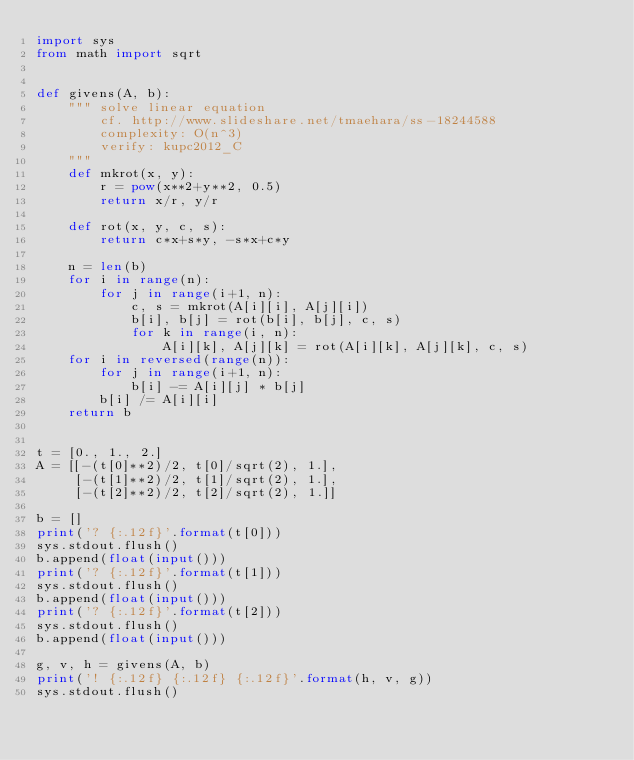<code> <loc_0><loc_0><loc_500><loc_500><_Python_>import sys
from math import sqrt


def givens(A, b):
    """ solve linear equation
        cf. http://www.slideshare.net/tmaehara/ss-18244588
        complexity: O(n^3)
        verify: kupc2012_C
    """
    def mkrot(x, y):
        r = pow(x**2+y**2, 0.5)
        return x/r, y/r

    def rot(x, y, c, s):
        return c*x+s*y, -s*x+c*y

    n = len(b)
    for i in range(n):
        for j in range(i+1, n):
            c, s = mkrot(A[i][i], A[j][i])
            b[i], b[j] = rot(b[i], b[j], c, s)
            for k in range(i, n):
                A[i][k], A[j][k] = rot(A[i][k], A[j][k], c, s)
    for i in reversed(range(n)):
        for j in range(i+1, n):
            b[i] -= A[i][j] * b[j]
        b[i] /= A[i][i]
    return b


t = [0., 1., 2.]
A = [[-(t[0]**2)/2, t[0]/sqrt(2), 1.],
     [-(t[1]**2)/2, t[1]/sqrt(2), 1.],
     [-(t[2]**2)/2, t[2]/sqrt(2), 1.]]

b = []
print('? {:.12f}'.format(t[0]))
sys.stdout.flush()
b.append(float(input()))
print('? {:.12f}'.format(t[1]))
sys.stdout.flush()
b.append(float(input()))
print('? {:.12f}'.format(t[2]))
sys.stdout.flush()
b.append(float(input()))

g, v, h = givens(A, b)
print('! {:.12f} {:.12f} {:.12f}'.format(h, v, g))
sys.stdout.flush()
</code> 